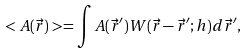Convert formula to latex. <formula><loc_0><loc_0><loc_500><loc_500>< A ( \vec { r } ) > = \int A ( \vec { r } ^ { \prime } ) W ( \vec { r } - \vec { r } ^ { \prime } ; h ) d \vec { r } ^ { \prime } ,</formula> 